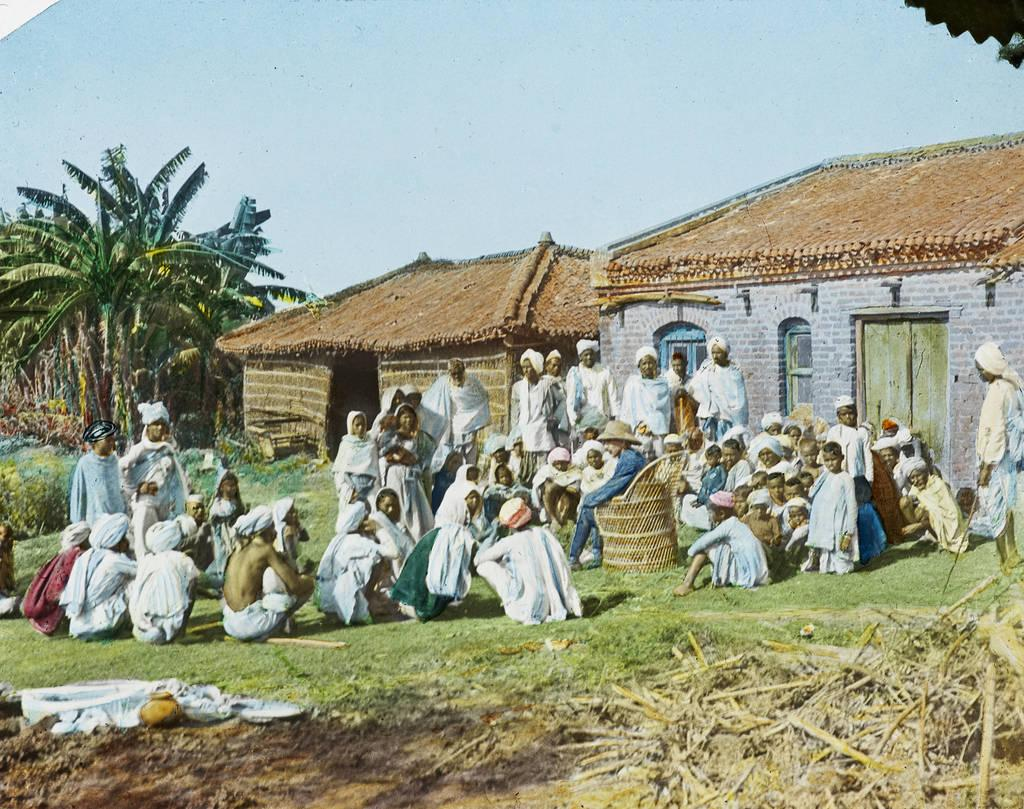What can be seen in the foreground of the image? There are objects, a chair, and a group of people on the grass in the foreground of the image. Can you describe the objects in the foreground? Unfortunately, the facts provided do not specify the nature of the objects in the foreground. What is visible in the background of the image? There are houses, trees, doors, and the sky visible in the background of the image. What time of day was the image taken? The image was taken during the day. Where is the hydrant located in the image? There is no hydrant present in the image. What type of animal can be seen interacting with the group of people on the grass? There is no animal present in the image; it only features a group of people on the grass. 